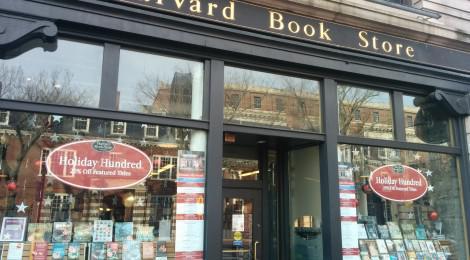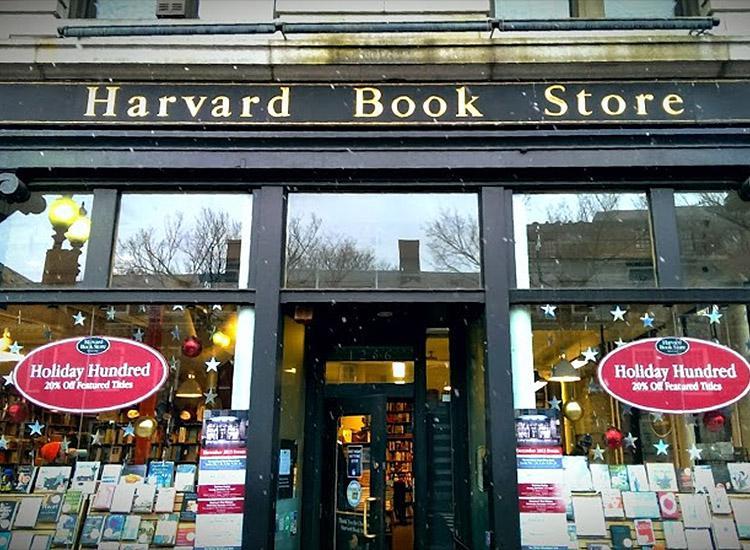The first image is the image on the left, the second image is the image on the right. For the images shown, is this caption "In one image, an awning with advertising extends over the front of a bookstore." true? Answer yes or no. No. 